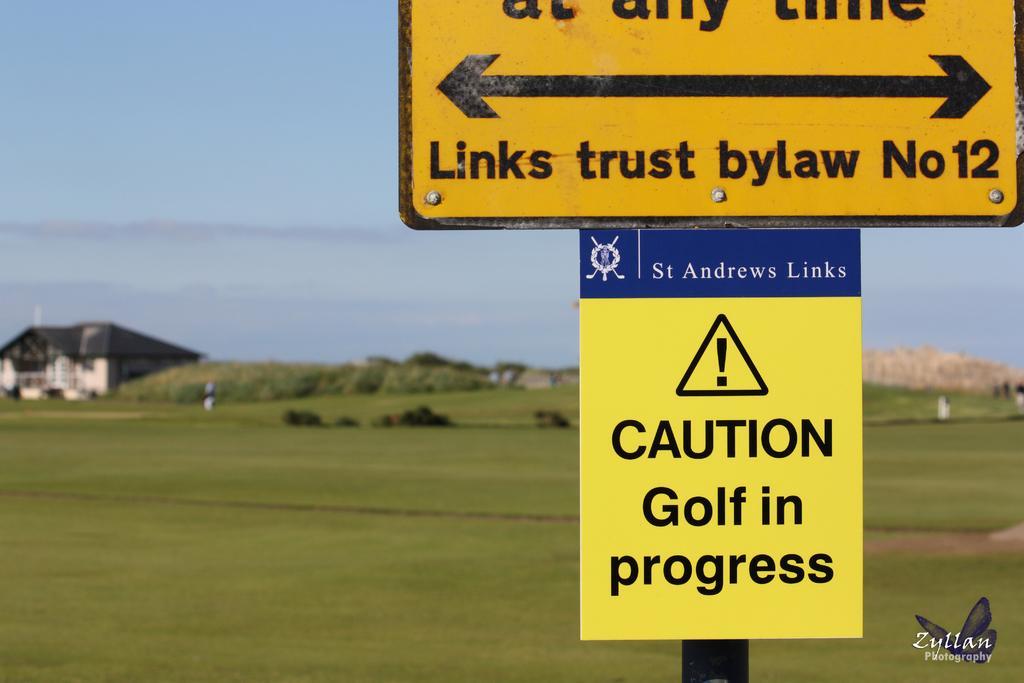Please provide a concise description of this image. We can see boards on pole and grass. In the background we can see trees,house and sky. In the bottom right of the image we can see logo and text. 